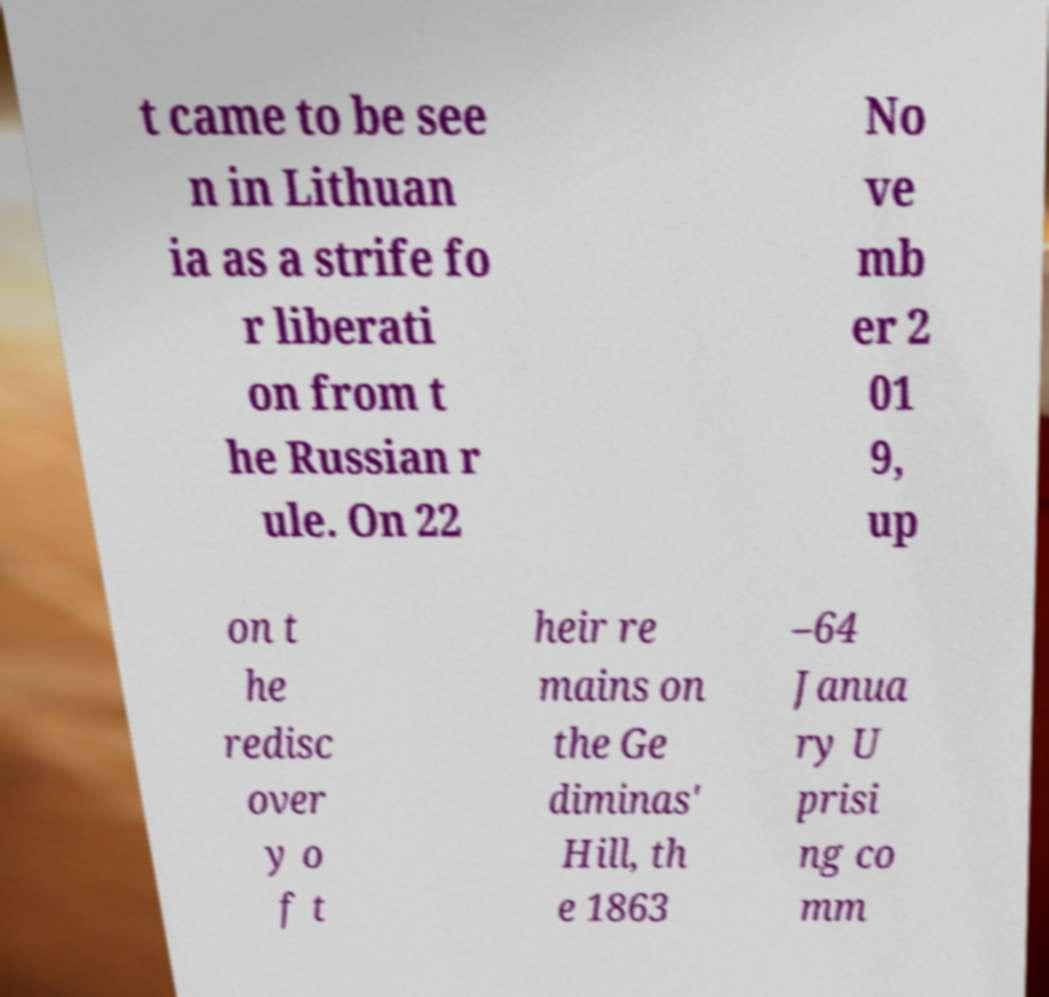Please identify and transcribe the text found in this image. t came to be see n in Lithuan ia as a strife fo r liberati on from t he Russian r ule. On 22 No ve mb er 2 01 9, up on t he redisc over y o f t heir re mains on the Ge diminas' Hill, th e 1863 –64 Janua ry U prisi ng co mm 